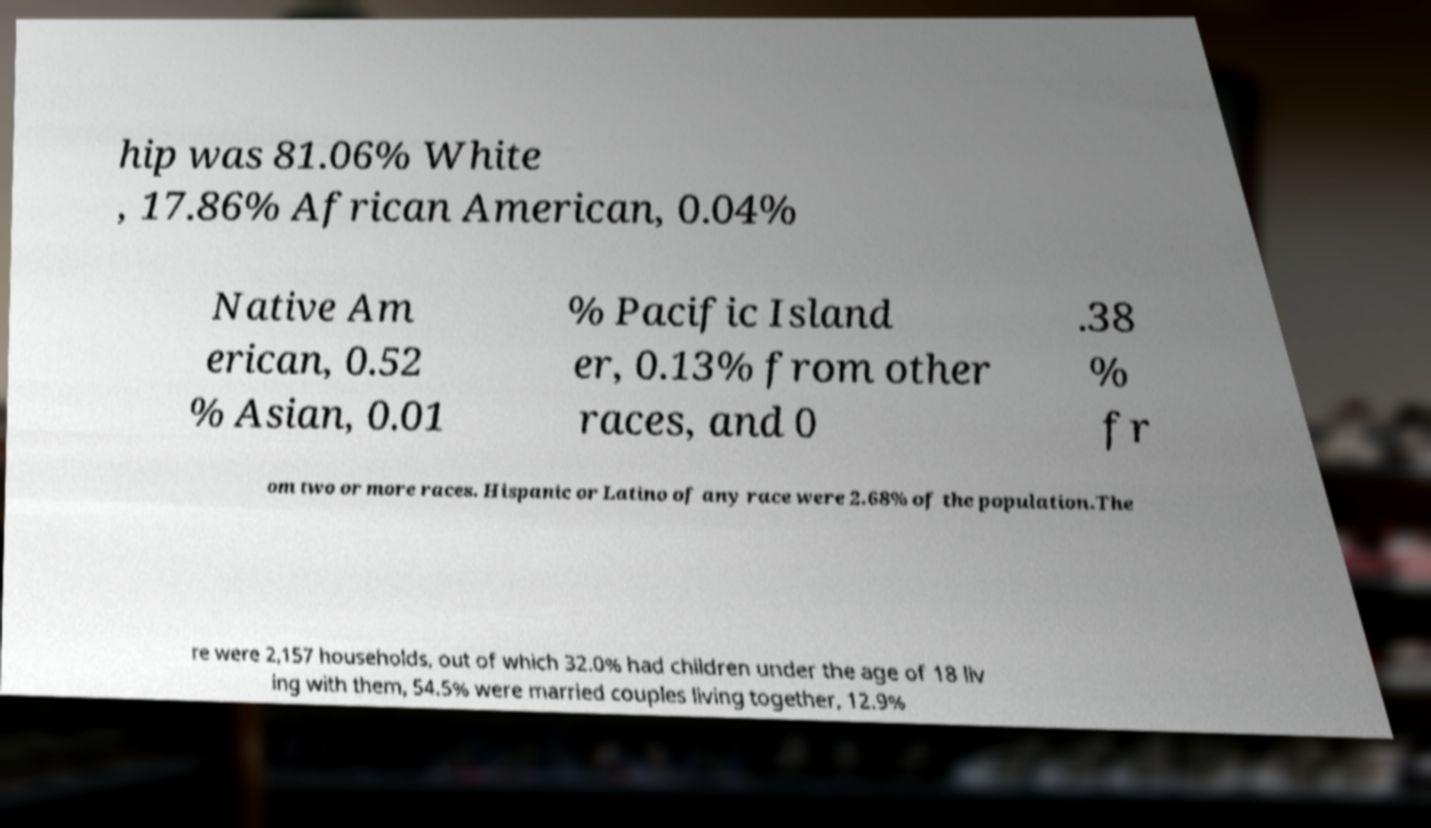For documentation purposes, I need the text within this image transcribed. Could you provide that? hip was 81.06% White , 17.86% African American, 0.04% Native Am erican, 0.52 % Asian, 0.01 % Pacific Island er, 0.13% from other races, and 0 .38 % fr om two or more races. Hispanic or Latino of any race were 2.68% of the population.The re were 2,157 households, out of which 32.0% had children under the age of 18 liv ing with them, 54.5% were married couples living together, 12.9% 